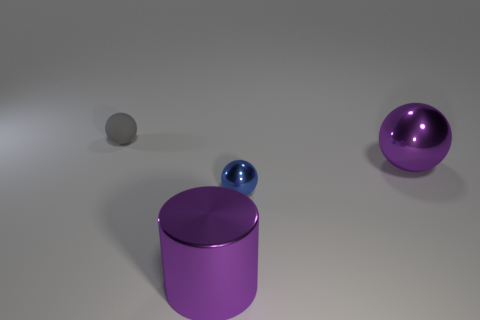Add 2 tiny gray rubber spheres. How many objects exist? 6 Subtract all cylinders. How many objects are left? 3 Add 4 tiny metal balls. How many tiny metal balls are left? 5 Add 2 tiny yellow rubber cylinders. How many tiny yellow rubber cylinders exist? 2 Subtract 0 cyan cubes. How many objects are left? 4 Subtract all large objects. Subtract all large rubber cylinders. How many objects are left? 2 